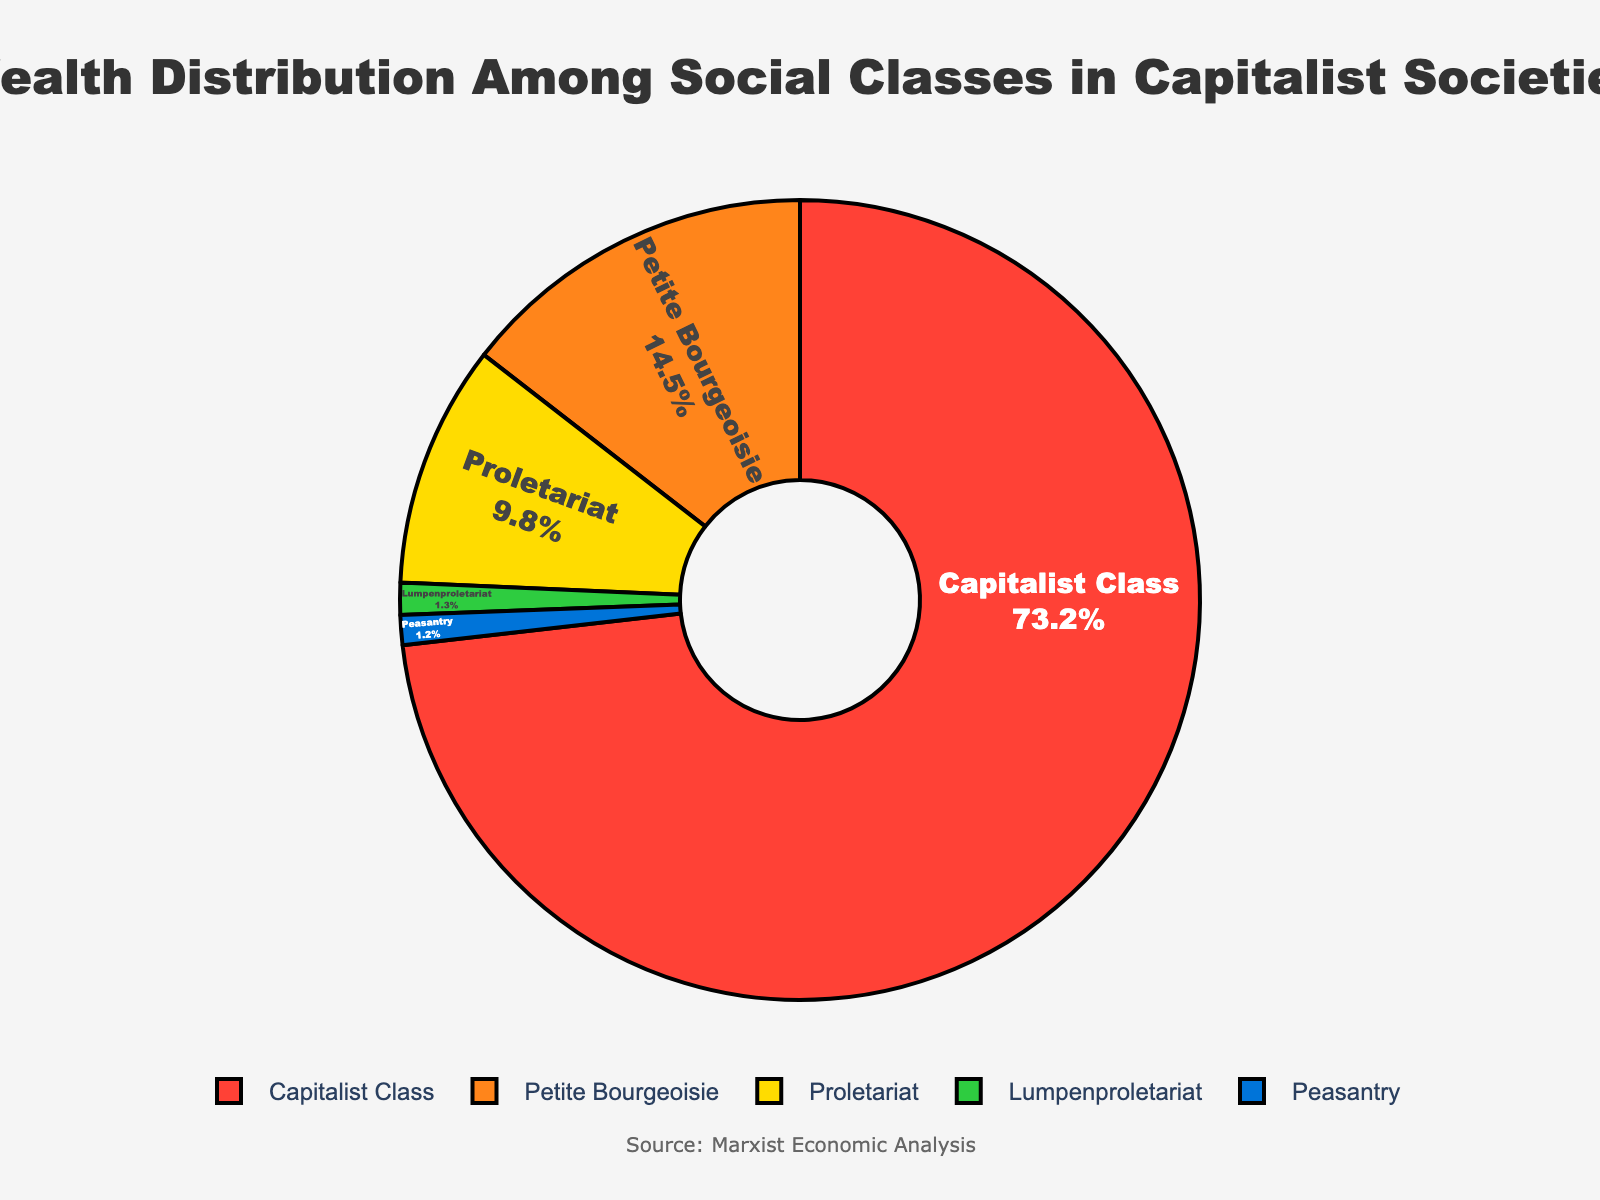What's the sum of wealth percentages for the Capitalist Class and Petite Bourgeoisie? To find the sum of the wealth percentages for the Capitalist Class and Petite Bourgeoisie, we simply add their percentages together: 73.2% (Capitalist Class) + 14.5% (Petite Bourgeoisie) = 87.7%
Answer: 87.7% Which social class has the smallest share of wealth? By examining the wealth percentages, the Peasantry has the smallest share at 1.2%
Answer: Peasantry What is the difference in wealth percentages between the Capitalist Class and the Proletariat? To find the difference, subtract the Proletariat's percentage from the Capitalist Class's percentage: 73.2% - 9.8% = 63.4%
Answer: 63.4% Which social class is represented by the smallest slice in the pie chart? Visually, the slice for the Peasantry is the smallest
Answer: Peasantry How much more wealth does the Capitalist Class hold compared to the Petite Bourgeoisie? To determine the difference, subtract the Petite Bourgeoisie's percentage from the Capitalist Class's: 73.2% - 14.5% = 58.7%
Answer: 58.7% If the total wealth were divided evenly among all groups, what would be the average wealth percentage per social class? There are 5 social classes. The average is calculated by dividing 100% by 5: 100% / 5 = 20%
Answer: 20% What two social classes together hold less wealth than the Proletariat alone? By summing the wealth percentages, the Peasantry and Lumpenproletariat together hold less wealth than the Proletariat: 1.2% (Peasantry) + 1.3% (Lumpenproletariat) = 2.5%, which is less than 9.8% (Proletariat)
Answer: Peasantry and Lumpenproletariat What percentage of wealth is held by the Lumpenproletariat? By examining the data, the Lumpenproletariat holds 1.3% of the wealth
Answer: 1.3% Which group has nearly ten times the wealth percentage of the Peasantry? The Petite Bourgeoisie holds 14.5% of the wealth, which is roughly ten times more than the 1.2% of the Peasantry
Answer: Petite Bourgeoisie What's the combined wealth percentage of the social classes other than the Capitalist Class? To find the combined wealth percentage of all classes except the Capitalist Class, sum the percentages of the Petite Bourgeoisie, Proletariat, Lumpenproletariat, and Peasantry: 14.5% + 9.8% + 1.3% + 1.2% = 26.8%
Answer: 26.8% 